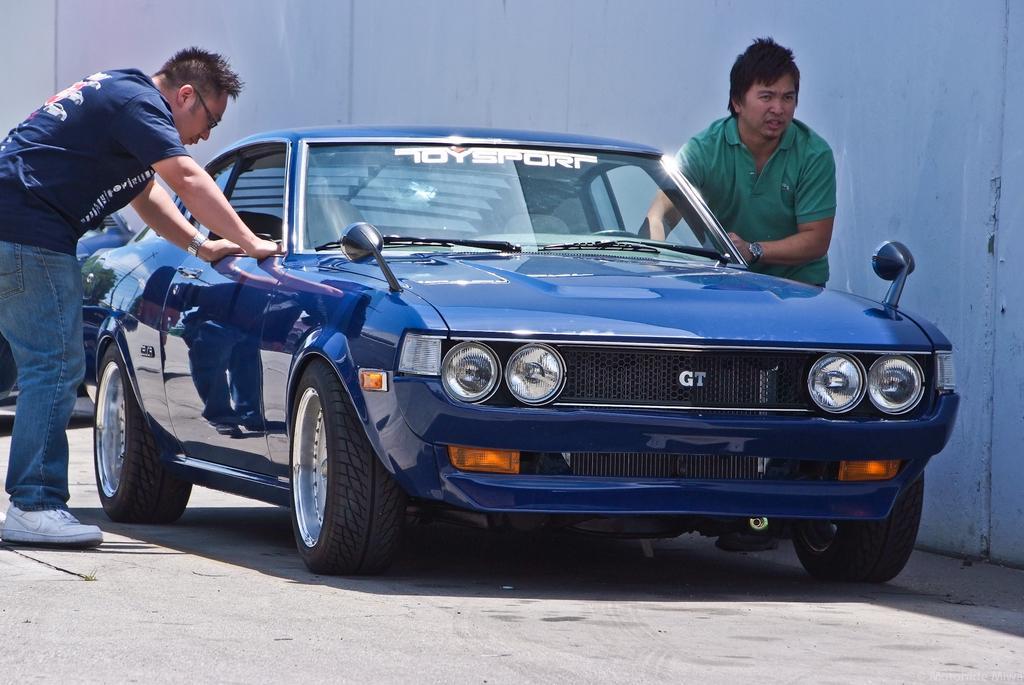Can you describe this image briefly? In this image, there is a car in between two persons beside the wall. 